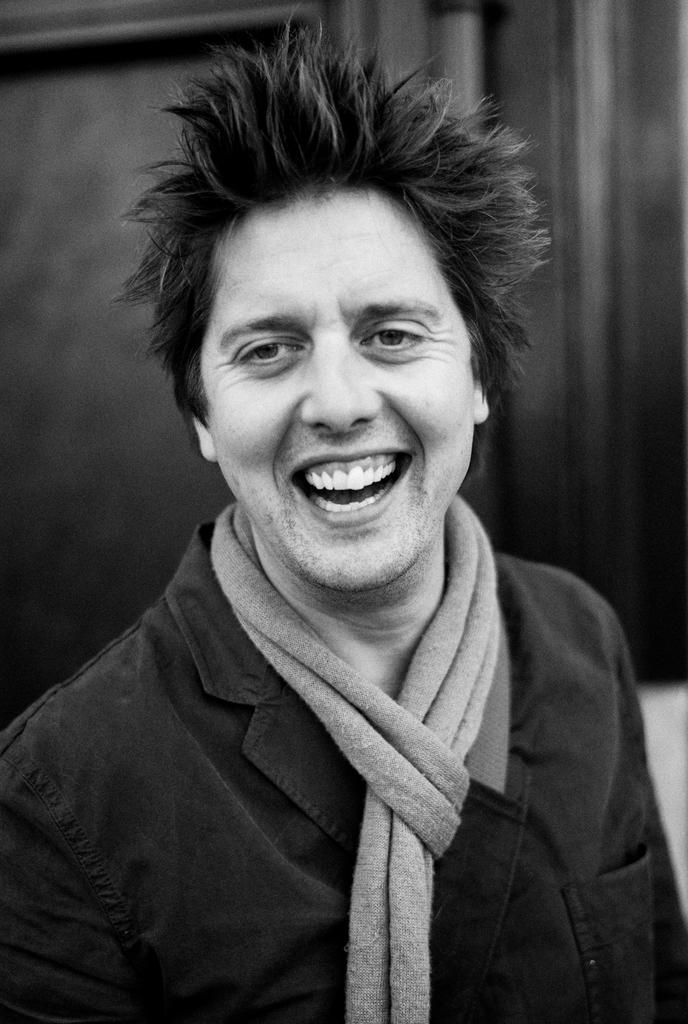What is the color scheme of the image? The image is black and white. What is the main subject of the image? There is a person standing in the center of the image. What is the person doing in the image? The person is smiling. What type of clothing is the person wearing? The person is wearing a dress and a scarf. How many pets are visible in the image? There are no pets visible in the image; it features a person standing in the center of the image. What type of stone is the person holding in the image? There is no stone present in the image; the person is wearing a dress and a scarf. 